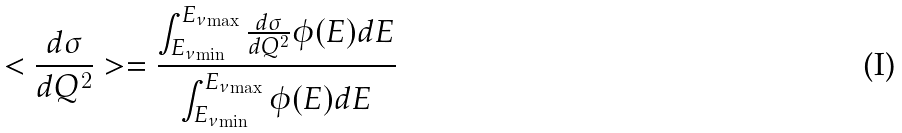<formula> <loc_0><loc_0><loc_500><loc_500>< \frac { d { \sigma } } { d Q ^ { 2 } } > = \frac { \int _ { { E _ { \nu } } _ { \min } } ^ { { E _ { \nu } } _ { \max } } \frac { d { \sigma } } { d Q ^ { 2 } } \phi ( E ) d E } { \int _ { { E _ { \nu } } _ { \min } } ^ { { E _ { \nu } } _ { \max } } \phi ( E ) d E }</formula> 